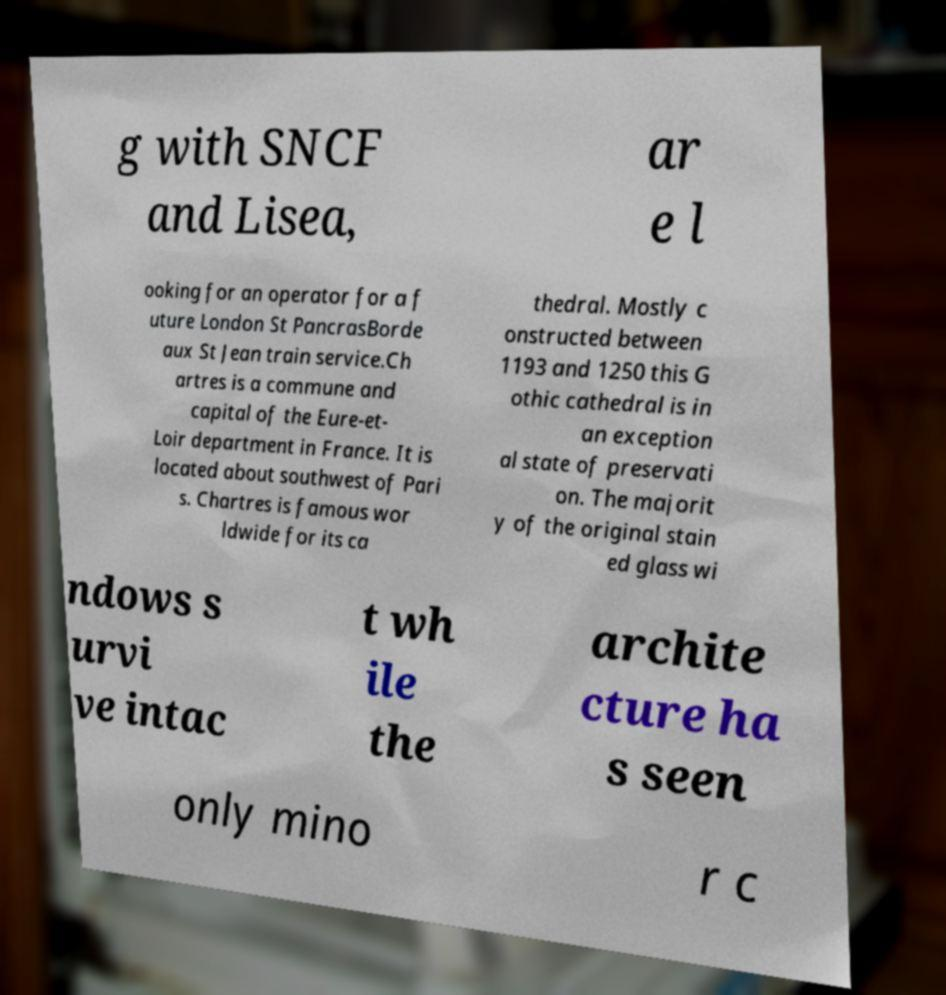Could you extract and type out the text from this image? g with SNCF and Lisea, ar e l ooking for an operator for a f uture London St PancrasBorde aux St Jean train service.Ch artres is a commune and capital of the Eure-et- Loir department in France. It is located about southwest of Pari s. Chartres is famous wor ldwide for its ca thedral. Mostly c onstructed between 1193 and 1250 this G othic cathedral is in an exception al state of preservati on. The majorit y of the original stain ed glass wi ndows s urvi ve intac t wh ile the archite cture ha s seen only mino r c 